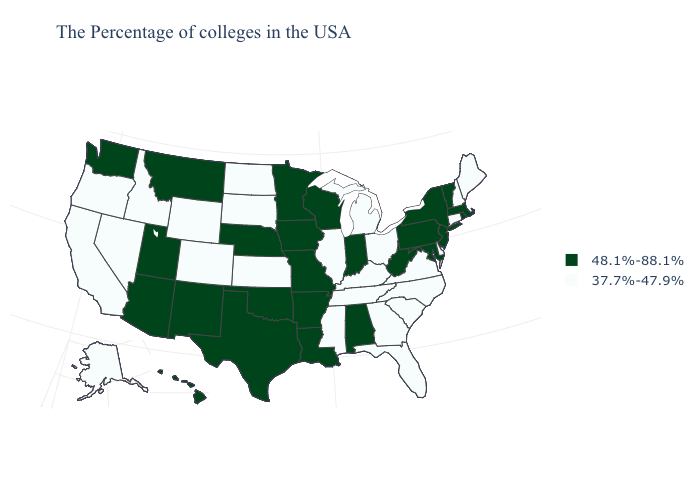What is the value of Maryland?
Give a very brief answer. 48.1%-88.1%. What is the value of Florida?
Concise answer only. 37.7%-47.9%. Does Florida have the same value as Hawaii?
Quick response, please. No. Among the states that border Ohio , which have the lowest value?
Concise answer only. Michigan, Kentucky. What is the lowest value in states that border Pennsylvania?
Concise answer only. 37.7%-47.9%. What is the value of Florida?
Keep it brief. 37.7%-47.9%. Does the map have missing data?
Short answer required. No. Does Maryland have the highest value in the USA?
Quick response, please. Yes. Does Wyoming have the same value as Montana?
Quick response, please. No. What is the value of West Virginia?
Answer briefly. 48.1%-88.1%. Name the states that have a value in the range 37.7%-47.9%?
Be succinct. Maine, New Hampshire, Connecticut, Delaware, Virginia, North Carolina, South Carolina, Ohio, Florida, Georgia, Michigan, Kentucky, Tennessee, Illinois, Mississippi, Kansas, South Dakota, North Dakota, Wyoming, Colorado, Idaho, Nevada, California, Oregon, Alaska. How many symbols are there in the legend?
Quick response, please. 2. Does South Dakota have the highest value in the USA?
Give a very brief answer. No. Does Wyoming have the highest value in the USA?
Write a very short answer. No. Name the states that have a value in the range 48.1%-88.1%?
Short answer required. Massachusetts, Rhode Island, Vermont, New York, New Jersey, Maryland, Pennsylvania, West Virginia, Indiana, Alabama, Wisconsin, Louisiana, Missouri, Arkansas, Minnesota, Iowa, Nebraska, Oklahoma, Texas, New Mexico, Utah, Montana, Arizona, Washington, Hawaii. 